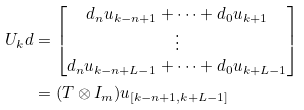<formula> <loc_0><loc_0><loc_500><loc_500>U _ { k } d & = \begin{bmatrix} d _ { n } u _ { k - n + 1 } + \dots + d _ { 0 } u _ { k + 1 } \\ \vdots \\ d _ { n } u _ { k - n + L - 1 } + \dots + d _ { 0 } u _ { k + L - 1 } \end{bmatrix} \\ & = ( T \otimes I _ { m } ) u _ { [ k - n + 1 , k + L - 1 ] }</formula> 